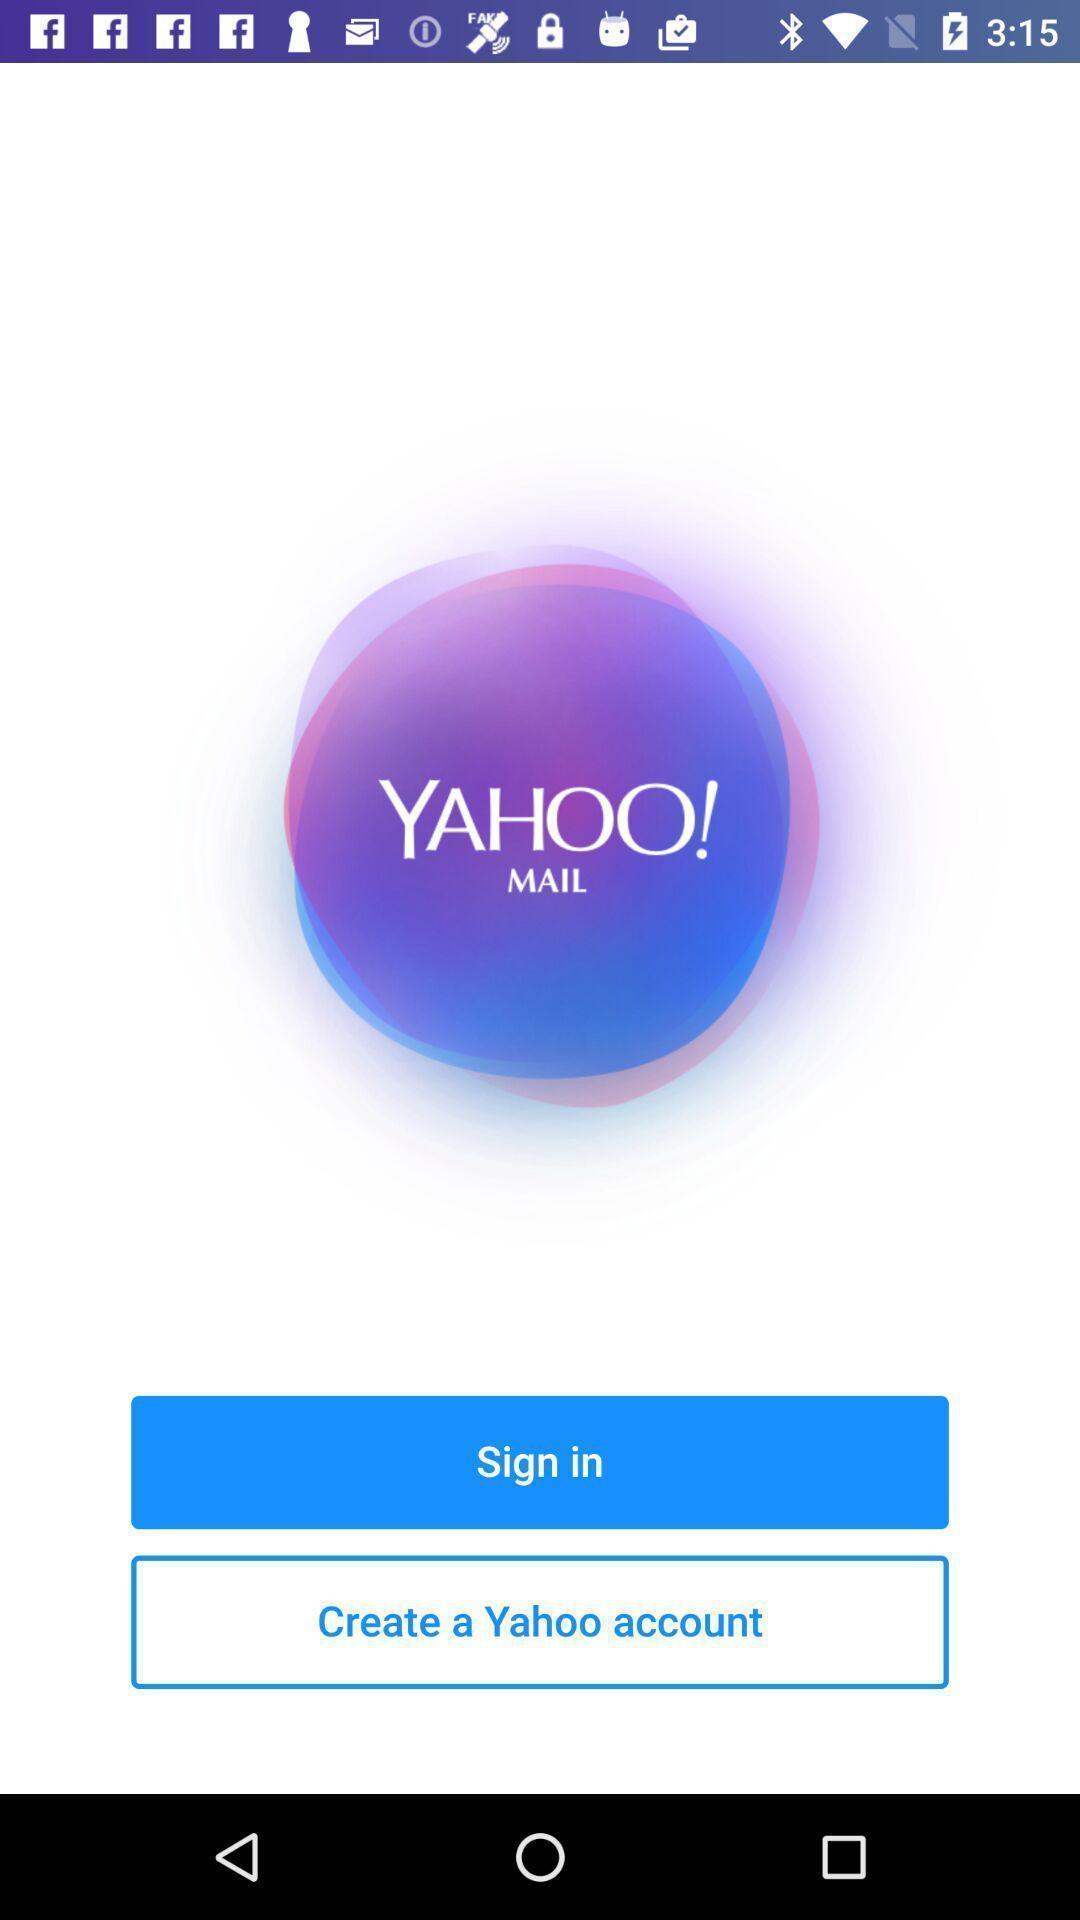Provide a textual representation of this image. Start page to sign in. 